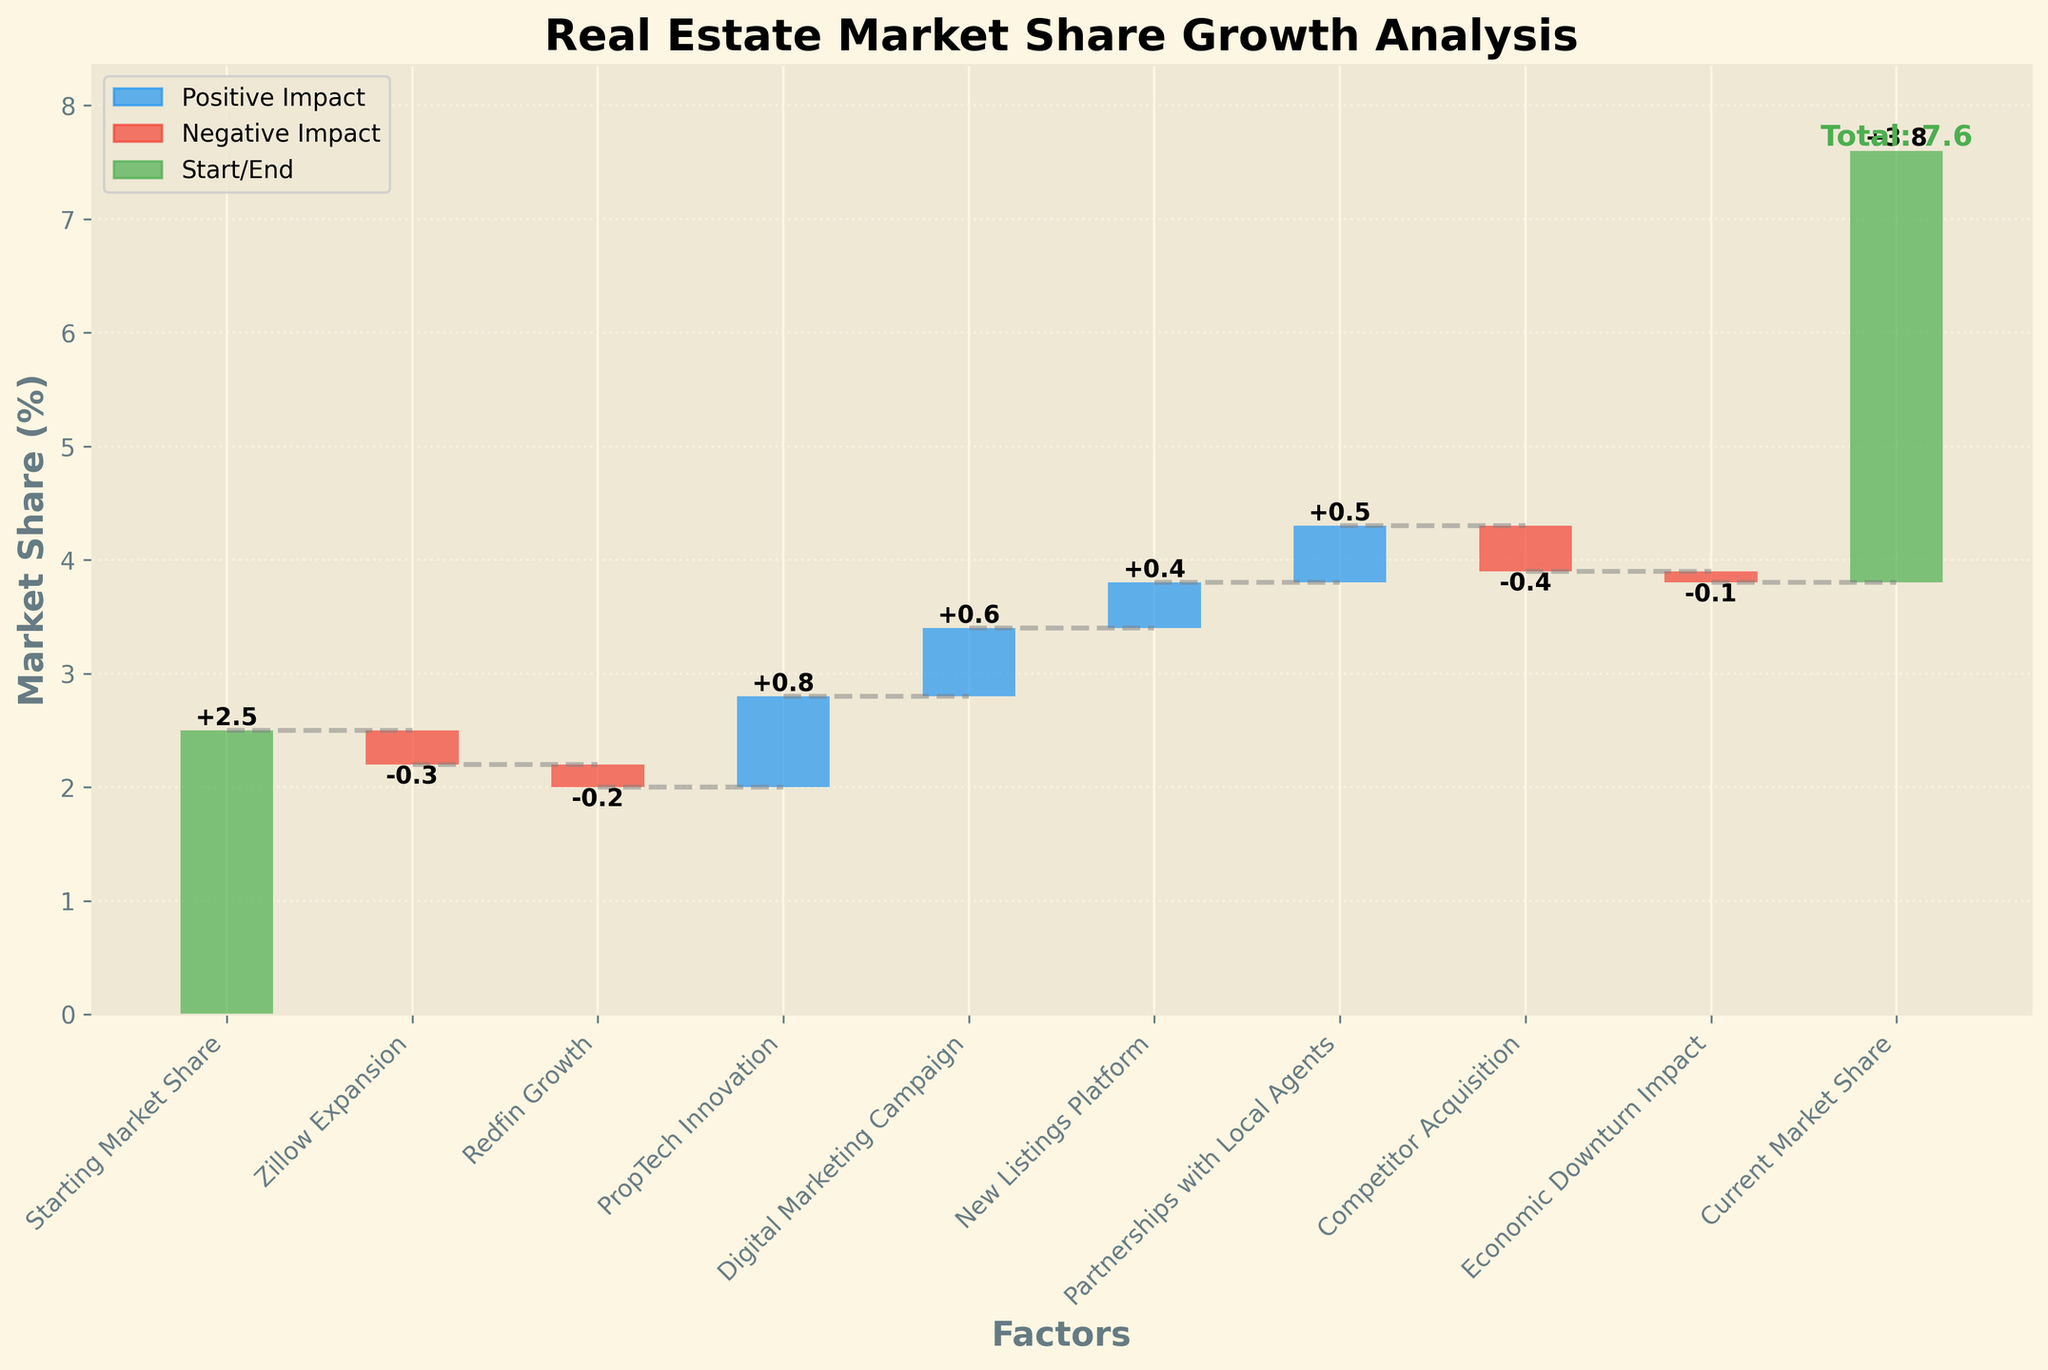How does the title of the chart describe its content? The title "Real Estate Market Share Growth Analysis" indicates that the chart is showing changes in market share over time, specifically for a real estate company. This suggests that the chart will break down the different factors that contributed to the growth of market share for the real estate startup.
Answer: It shows changes in market share over time What is the starting market share? According to the first bar which is green and labeled "Starting Market Share," the value is 2.5%.
Answer: 2.5% What is the ending market share? The last bar labeled "Current Market Share" is also green and shows that the final market share value is 3.8%.
Answer: 3.8% How many factors contributed to the market share changes? By counting the number of bars between the "Starting Market Share" and "Current Market Share," excluding these two, you find that 8 factors contributed to the changes.
Answer: 8 Which factor had the largest positive impact on market share? Among the blue bars (indicating positive impact), "PropTech Innovation" had the highest increase of 0.8%.
Answer: PropTech Innovation, 0.8% Which factor had the largest negative impact on market share? Among the red bars (indicating negative impact), "Competitor Acquisition" had the highest decrease of -0.4%.
Answer: Competitor Acquisition, -0.4% What is the cumulative impact of "Zillow Expansion" and "Redfin Growth"? Both factors are negative, so you need to add them together: -0.3 + (-0.2) = -0.5%.
Answer: -0.5% What is the net effect of all positive impacts combined? The positive impacts are "PropTech Innovation" (0.8), "Digital Marketing Campaign" (0.6), "New Listings Platform" (0.4), and "Partnerships with Local Agents" (0.5). Summing these up: 0.8 + 0.6 + 0.4 + 0.5 = 2.3%.
Answer: 2.3% What were the values of the two largest positive impacts? The two largest positive impacts are "PropTech Innovation" at 0.8% and "Digital Marketing Campaign" at 0.6%.
Answer: 0.8% and 0.6% What is the total contribution of negative impacts? The negative impacts are "Zillow Expansion" (-0.3), "Redfin Growth" (-0.2), "Competitor Acquisition" (-0.4), and "Economic Downturn Impact" (-0.1). Summing these up: -0.3 + (-0.2) + (-0.4) + (-0.1) = -1.0%.
Answer: -1.0% 